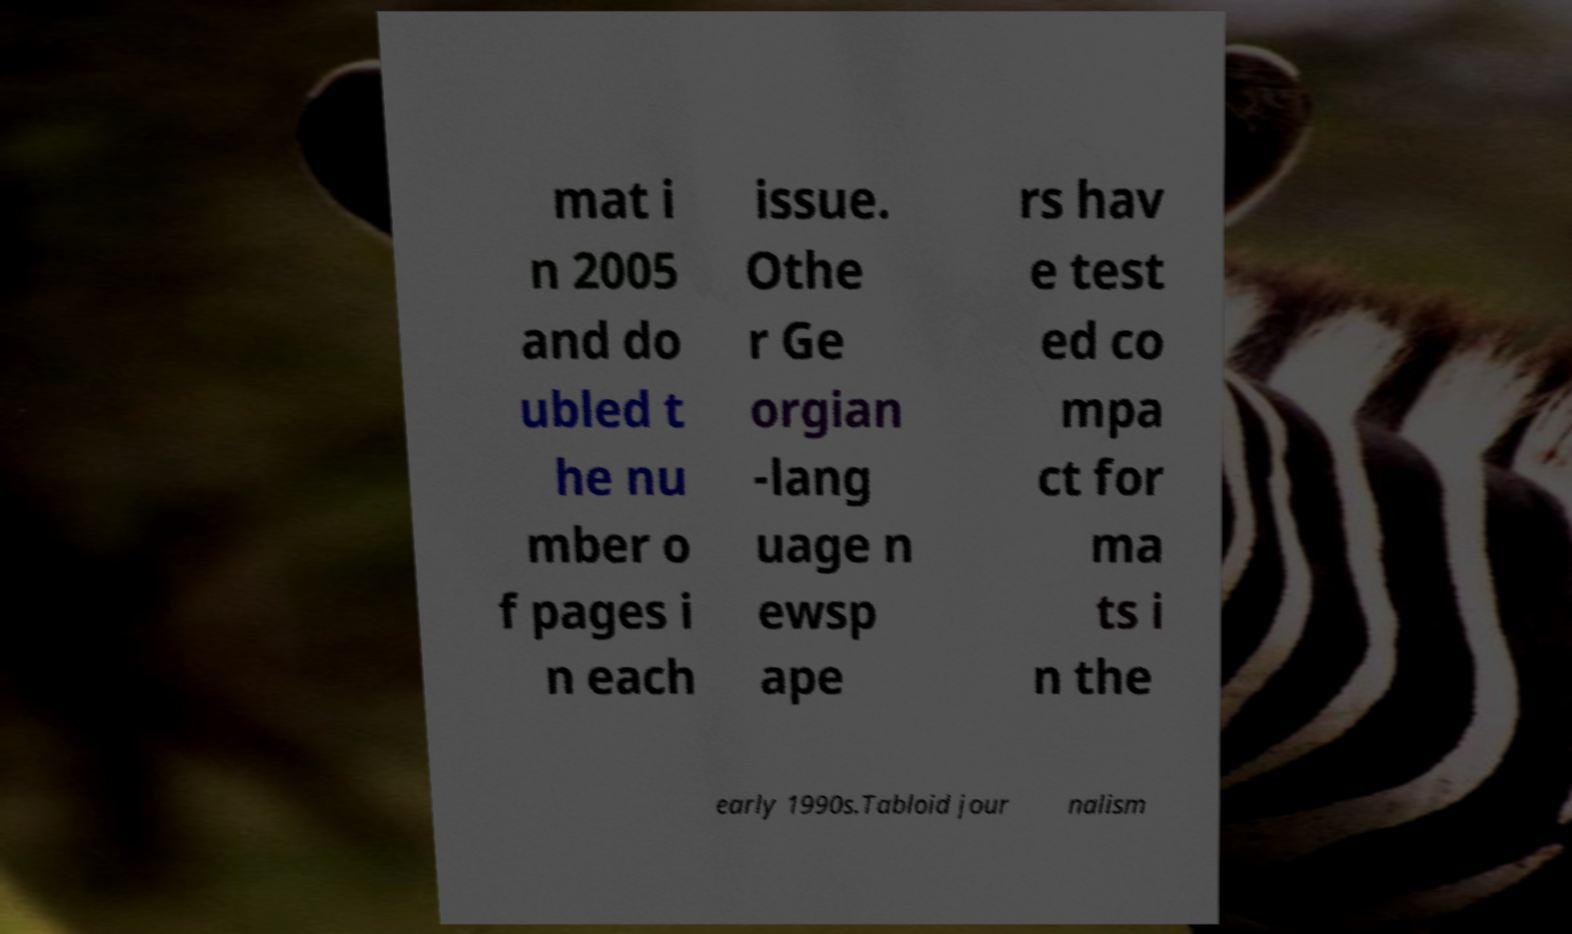Please identify and transcribe the text found in this image. mat i n 2005 and do ubled t he nu mber o f pages i n each issue. Othe r Ge orgian -lang uage n ewsp ape rs hav e test ed co mpa ct for ma ts i n the early 1990s.Tabloid jour nalism 